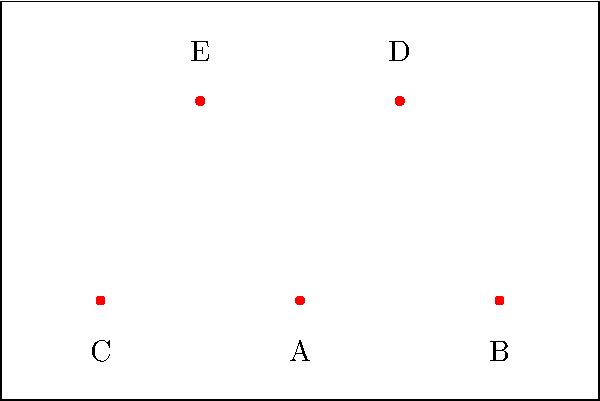In a ballet performance, five dancers (A, B, C, D, and E) are positioned on stage as shown in the diagram. The choreographer wants to create a symmetrical formation by moving only one dancer. Which dancer should be moved, and to what position, to achieve perfect symmetry while maintaining the overall shape of the formation? To solve this problem, let's follow these steps:

1. Analyze the current formation:
   - Dancers A, B, and C form a horizontal line at the bottom.
   - Dancers D and E are positioned above the line.

2. Identify the axis of symmetry:
   - The vertical line passing through dancer A is the potential axis of symmetry.

3. Check for symmetry:
   - B and C are equidistant from A, creating symmetry on the bottom line.
   - D and E are not symmetrical about the vertical axis through A.

4. Determine which dancer to move:
   - Moving either D or E would be sufficient to create symmetry.
   - Let's choose to move dancer E, as it requires the least movement.

5. Calculate the new position for E:
   - D is positioned at (1,2) relative to A at (0,0).
   - For symmetry, E should be at (-1,2) relative to A.

6. Verify the new formation:
   - After moving E to (-1,2), the formation will be perfectly symmetrical.
   - The overall V-shape of the formation is maintained.

Therefore, to achieve perfect symmetry while maintaining the overall shape, dancer E should be moved to the position (-1,2) relative to dancer A's position.
Answer: Move dancer E to position (-1,2) relative to A. 